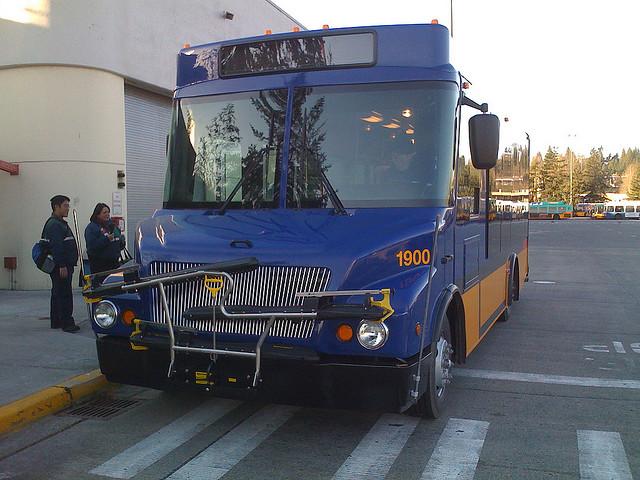Is this public transportation?
Concise answer only. Yes. What number is on the bus?
Answer briefly. 1900. Are people getting on the bus?
Give a very brief answer. Yes. Is the photo in black and white or color?
Answer briefly. Color. What is the yellow thing in the picture?
Give a very brief answer. Curb. 